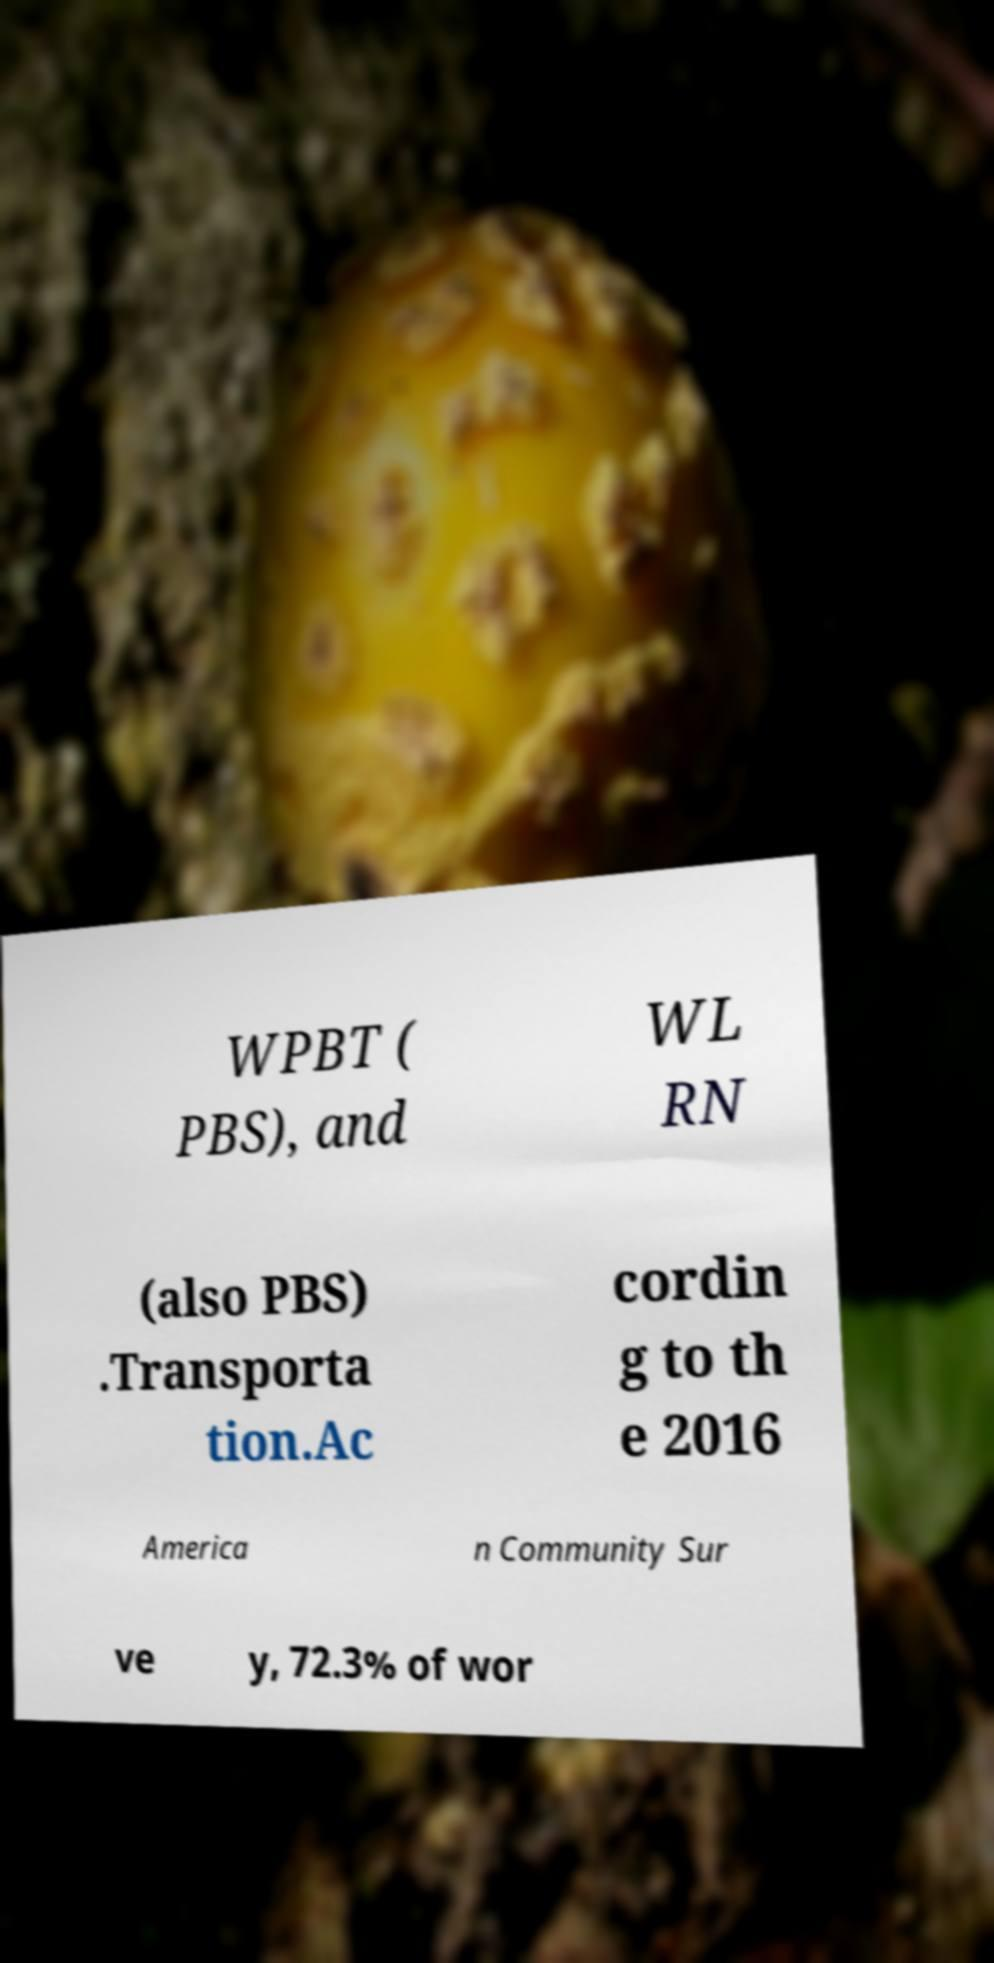For documentation purposes, I need the text within this image transcribed. Could you provide that? WPBT ( PBS), and WL RN (also PBS) .Transporta tion.Ac cordin g to th e 2016 America n Community Sur ve y, 72.3% of wor 